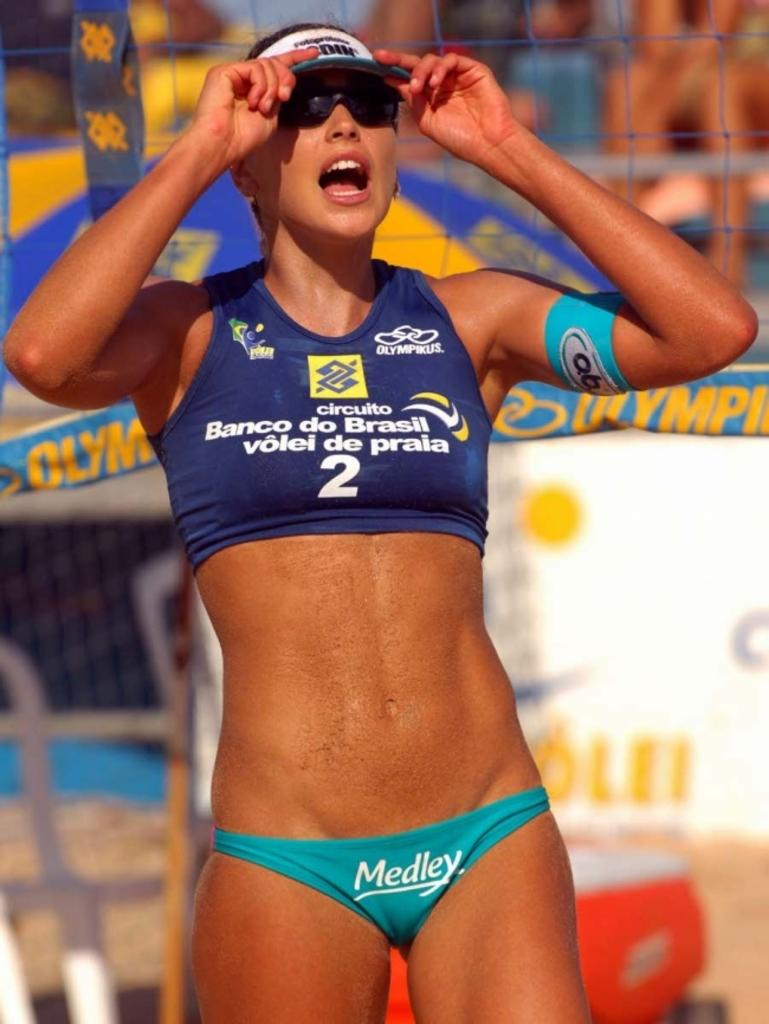<image>
Give a short and clear explanation of the subsequent image. A lady wearing a swim suit with the word Medley on the bottom. 